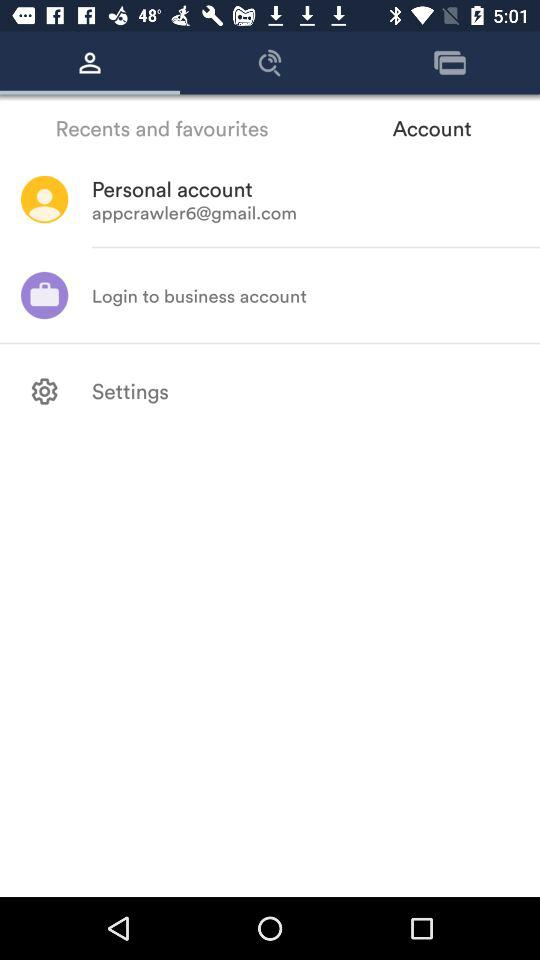Which tab has been selected? The tab that has been selected is "Personal". 